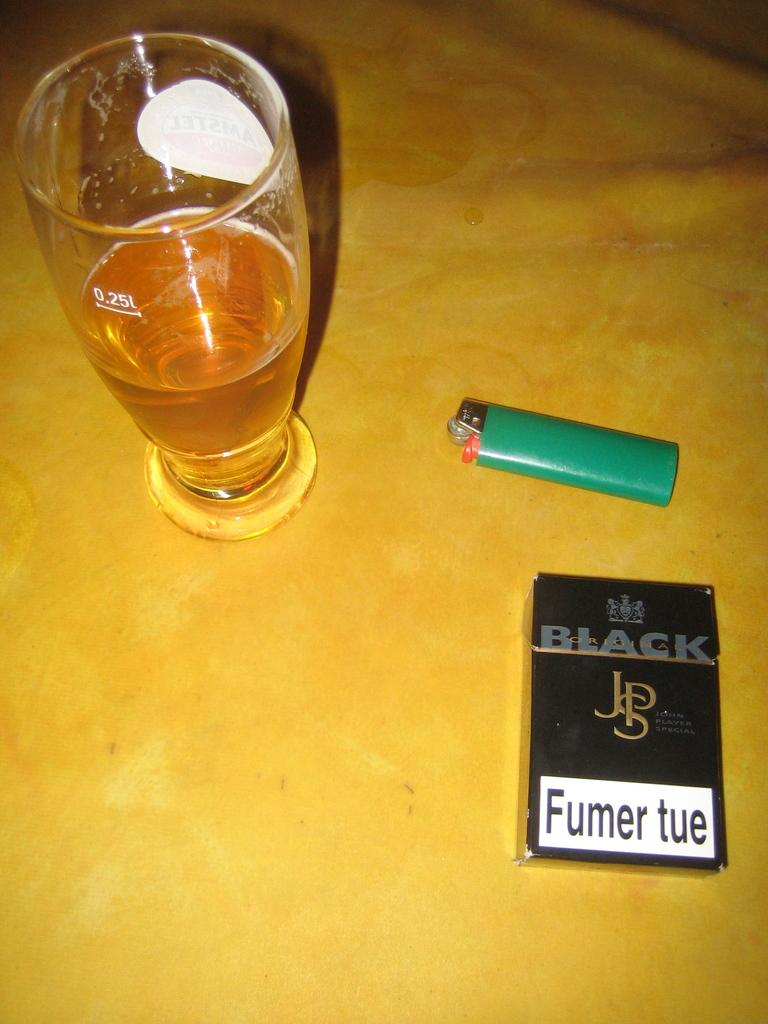<image>
Provide a brief description of the given image. A pack of cigarettes has a white label that says Fumer tue on it. 